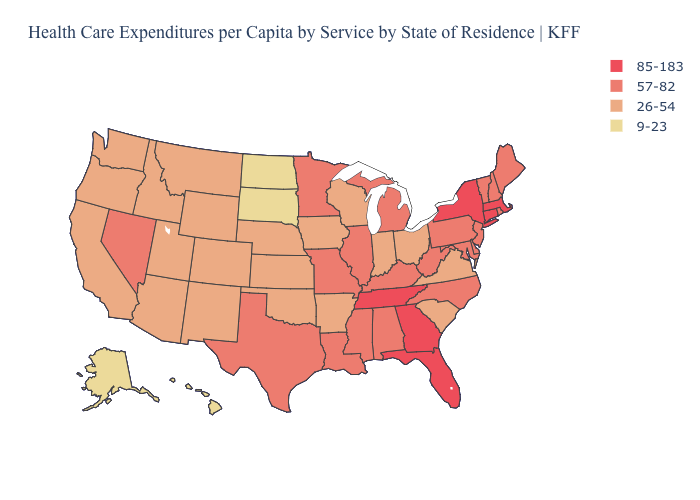What is the highest value in states that border Indiana?
Be succinct. 57-82. What is the highest value in the USA?
Give a very brief answer. 85-183. What is the value of Indiana?
Be succinct. 26-54. What is the value of Alaska?
Short answer required. 9-23. Name the states that have a value in the range 57-82?
Give a very brief answer. Alabama, Delaware, Illinois, Kentucky, Louisiana, Maine, Maryland, Michigan, Minnesota, Mississippi, Missouri, Nevada, New Hampshire, New Jersey, North Carolina, Pennsylvania, Rhode Island, Texas, Vermont, West Virginia. What is the value of Illinois?
Keep it brief. 57-82. What is the lowest value in states that border Montana?
Keep it brief. 9-23. Name the states that have a value in the range 57-82?
Quick response, please. Alabama, Delaware, Illinois, Kentucky, Louisiana, Maine, Maryland, Michigan, Minnesota, Mississippi, Missouri, Nevada, New Hampshire, New Jersey, North Carolina, Pennsylvania, Rhode Island, Texas, Vermont, West Virginia. Among the states that border Rhode Island , which have the lowest value?
Short answer required. Connecticut, Massachusetts. Which states have the highest value in the USA?
Keep it brief. Connecticut, Florida, Georgia, Massachusetts, New York, Tennessee. Which states have the lowest value in the South?
Keep it brief. Arkansas, Oklahoma, South Carolina, Virginia. Is the legend a continuous bar?
Give a very brief answer. No. What is the value of New Jersey?
Keep it brief. 57-82. What is the lowest value in the MidWest?
Answer briefly. 9-23. What is the lowest value in the South?
Concise answer only. 26-54. 